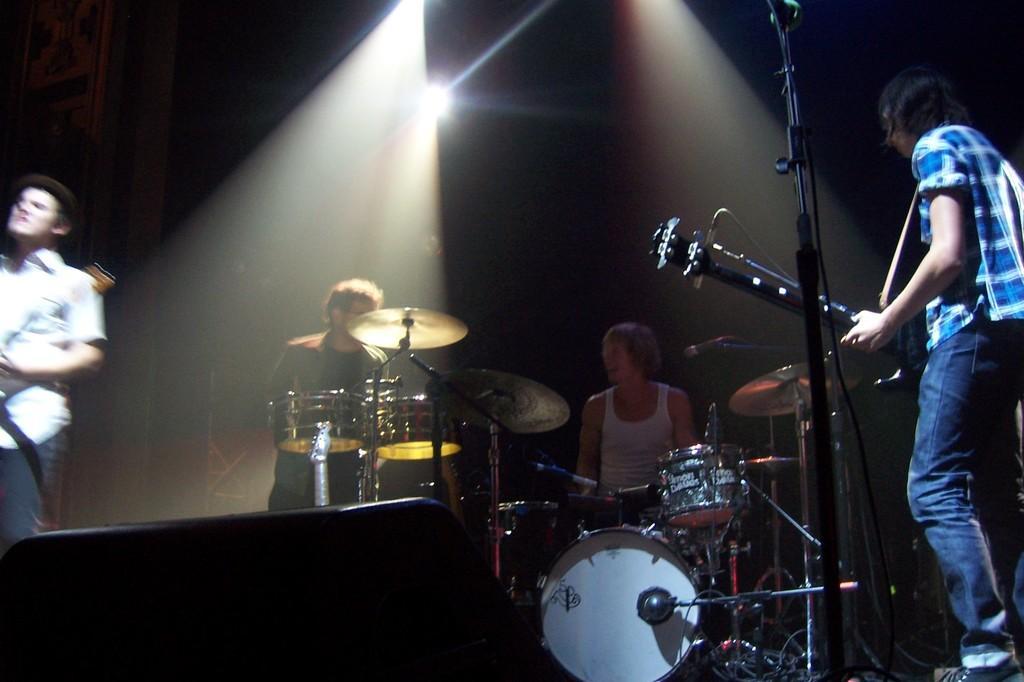Describe this image in one or two sentences. On the stage there are four people. To the right there is a man with blue checks shirt is standing and playing guitar. And the man with the white dress is sitting and playing drums. And the other man is also playing drums. To the left side a man with white shirt is also playing guitar. On the top there are lights. 